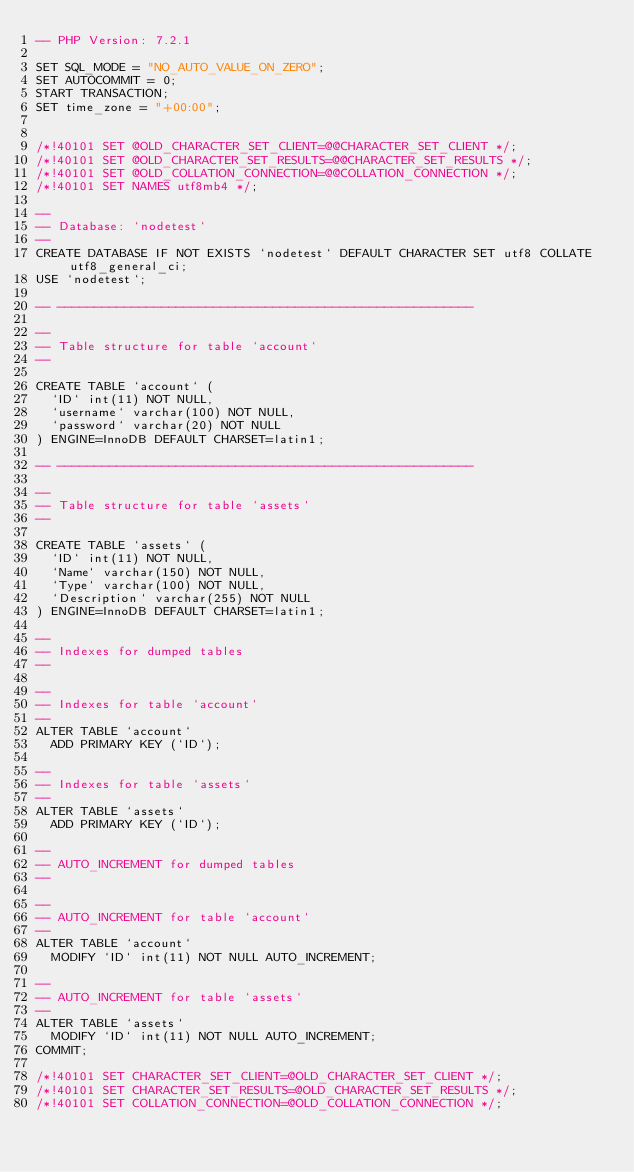Convert code to text. <code><loc_0><loc_0><loc_500><loc_500><_SQL_>-- PHP Version: 7.2.1

SET SQL_MODE = "NO_AUTO_VALUE_ON_ZERO";
SET AUTOCOMMIT = 0;
START TRANSACTION;
SET time_zone = "+00:00";


/*!40101 SET @OLD_CHARACTER_SET_CLIENT=@@CHARACTER_SET_CLIENT */;
/*!40101 SET @OLD_CHARACTER_SET_RESULTS=@@CHARACTER_SET_RESULTS */;
/*!40101 SET @OLD_COLLATION_CONNECTION=@@COLLATION_CONNECTION */;
/*!40101 SET NAMES utf8mb4 */;

--
-- Database: `nodetest`
--
CREATE DATABASE IF NOT EXISTS `nodetest` DEFAULT CHARACTER SET utf8 COLLATE utf8_general_ci;
USE `nodetest`;

-- --------------------------------------------------------

--
-- Table structure for table `account`
--

CREATE TABLE `account` (
  `ID` int(11) NOT NULL,
  `username` varchar(100) NOT NULL,
  `password` varchar(20) NOT NULL
) ENGINE=InnoDB DEFAULT CHARSET=latin1;

-- --------------------------------------------------------

--
-- Table structure for table `assets`
--

CREATE TABLE `assets` (
  `ID` int(11) NOT NULL,
  `Name` varchar(150) NOT NULL,
  `Type` varchar(100) NOT NULL,
  `Description` varchar(255) NOT NULL
) ENGINE=InnoDB DEFAULT CHARSET=latin1;

--
-- Indexes for dumped tables
--

--
-- Indexes for table `account`
--
ALTER TABLE `account`
  ADD PRIMARY KEY (`ID`);

--
-- Indexes for table `assets`
--
ALTER TABLE `assets`
  ADD PRIMARY KEY (`ID`);

--
-- AUTO_INCREMENT for dumped tables
--

--
-- AUTO_INCREMENT for table `account`
--
ALTER TABLE `account`
  MODIFY `ID` int(11) NOT NULL AUTO_INCREMENT;

--
-- AUTO_INCREMENT for table `assets`
--
ALTER TABLE `assets`
  MODIFY `ID` int(11) NOT NULL AUTO_INCREMENT;
COMMIT;

/*!40101 SET CHARACTER_SET_CLIENT=@OLD_CHARACTER_SET_CLIENT */;
/*!40101 SET CHARACTER_SET_RESULTS=@OLD_CHARACTER_SET_RESULTS */;
/*!40101 SET COLLATION_CONNECTION=@OLD_COLLATION_CONNECTION */;
</code> 